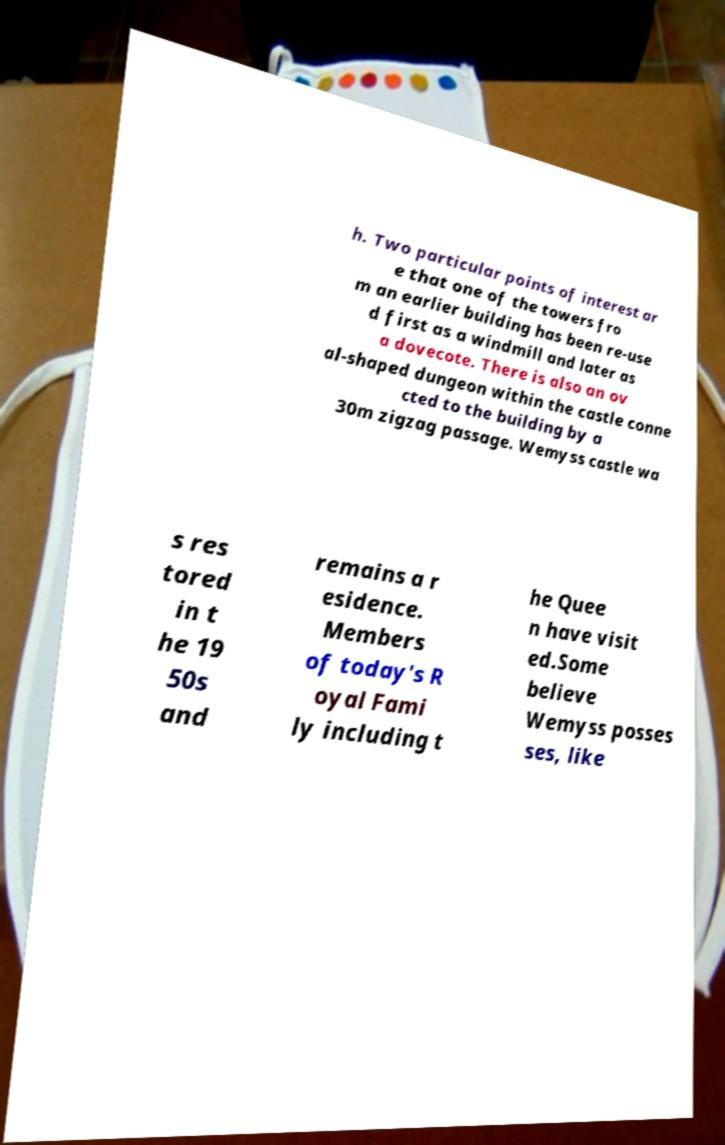What messages or text are displayed in this image? I need them in a readable, typed format. h. Two particular points of interest ar e that one of the towers fro m an earlier building has been re-use d first as a windmill and later as a dovecote. There is also an ov al-shaped dungeon within the castle conne cted to the building by a 30m zigzag passage. Wemyss castle wa s res tored in t he 19 50s and remains a r esidence. Members of today's R oyal Fami ly including t he Quee n have visit ed.Some believe Wemyss posses ses, like 